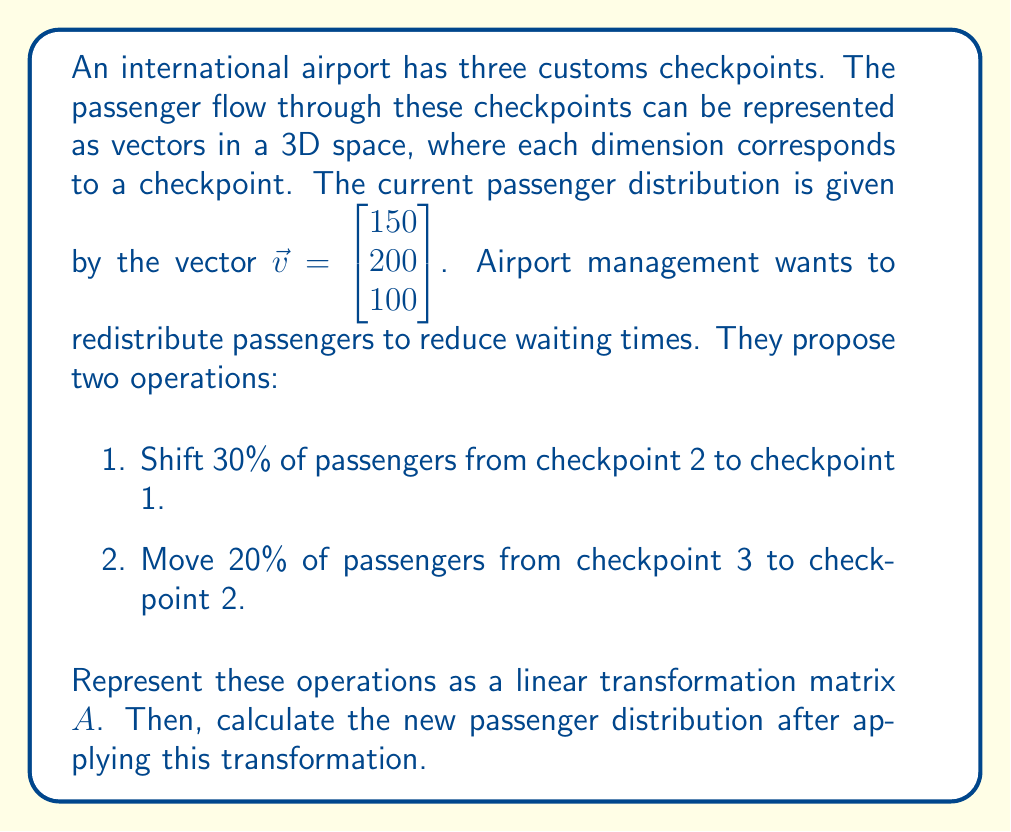Show me your answer to this math problem. To solve this problem, we'll follow these steps:

1. Construct the transformation matrix $A$.
2. Apply the transformation to the initial vector $\vec{v}$.

Step 1: Constructing the transformation matrix $A$

The transformation matrix $A$ will represent both operations simultaneously:

- Checkpoint 1 receives 30% from checkpoint 2, so it keeps 100% of its own passengers plus 30% from checkpoint 2.
- Checkpoint 2 loses 30% to checkpoint 1, keeps 70% of its own, and gains 20% from checkpoint 3.
- Checkpoint 3 loses 20% to checkpoint 2 and keeps 80% of its own.

Therefore, the transformation matrix $A$ is:

$$A = \begin{bmatrix}
1 & 0.3 & 0 \\
0 & 0.7 & 0.2 \\
0 & 0 & 0.8
\end{bmatrix}$$

Step 2: Applying the transformation

To find the new passenger distribution, we multiply $A$ by $\vec{v}$:

$$A\vec{v} = \begin{bmatrix}
1 & 0.3 & 0 \\
0 & 0.7 & 0.2 \\
0 & 0 & 0.8
\end{bmatrix} \begin{bmatrix}
150 \\
200 \\
100
\end{bmatrix}$$

Calculating this multiplication:

$$\begin{aligned}
A\vec{v} &= \begin{bmatrix}
(1 \times 150) + (0.3 \times 200) + (0 \times 100) \\
(0 \times 150) + (0.7 \times 200) + (0.2 \times 100) \\
(0 \times 150) + (0 \times 200) + (0.8 \times 100)
\end{bmatrix} \\[10pt]
&= \begin{bmatrix}
150 + 60 \\
140 + 20 \\
80
\end{bmatrix} \\[10pt]
&= \begin{bmatrix}
210 \\
160 \\
80
\end{bmatrix}
\end{aligned}$$
Answer: The new passenger distribution after applying the transformation is $\begin{bmatrix} 210 \\ 160 \\ 80 \end{bmatrix}$. 